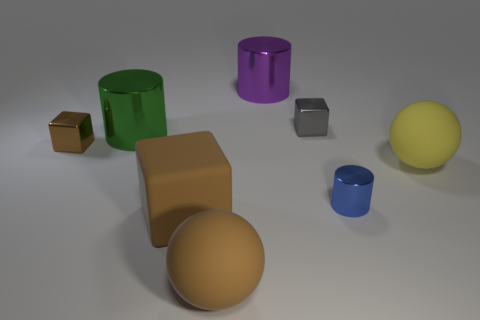Is there a large yellow thing of the same shape as the small gray object?
Offer a terse response. No. Is the brown sphere made of the same material as the cylinder to the right of the large purple metallic cylinder?
Keep it short and to the point. No. Is there a ball that has the same color as the tiny cylinder?
Give a very brief answer. No. What number of other things are the same material as the tiny brown cube?
Your response must be concise. 4. Is the color of the big cube the same as the small block left of the large green cylinder?
Give a very brief answer. Yes. Are there more purple shiny cylinders in front of the blue metallic object than blue shiny objects?
Offer a very short reply. No. There is a brown block that is in front of the sphere that is on the right side of the gray metal cube; what number of small brown metallic objects are in front of it?
Ensure brevity in your answer.  0. Do the brown matte thing that is in front of the brown matte block and the tiny brown metal thing have the same shape?
Provide a succinct answer. No. There is a cylinder that is behind the gray thing; what is it made of?
Ensure brevity in your answer.  Metal. There is a rubber thing that is both right of the big brown cube and in front of the blue thing; what is its shape?
Give a very brief answer. Sphere. 